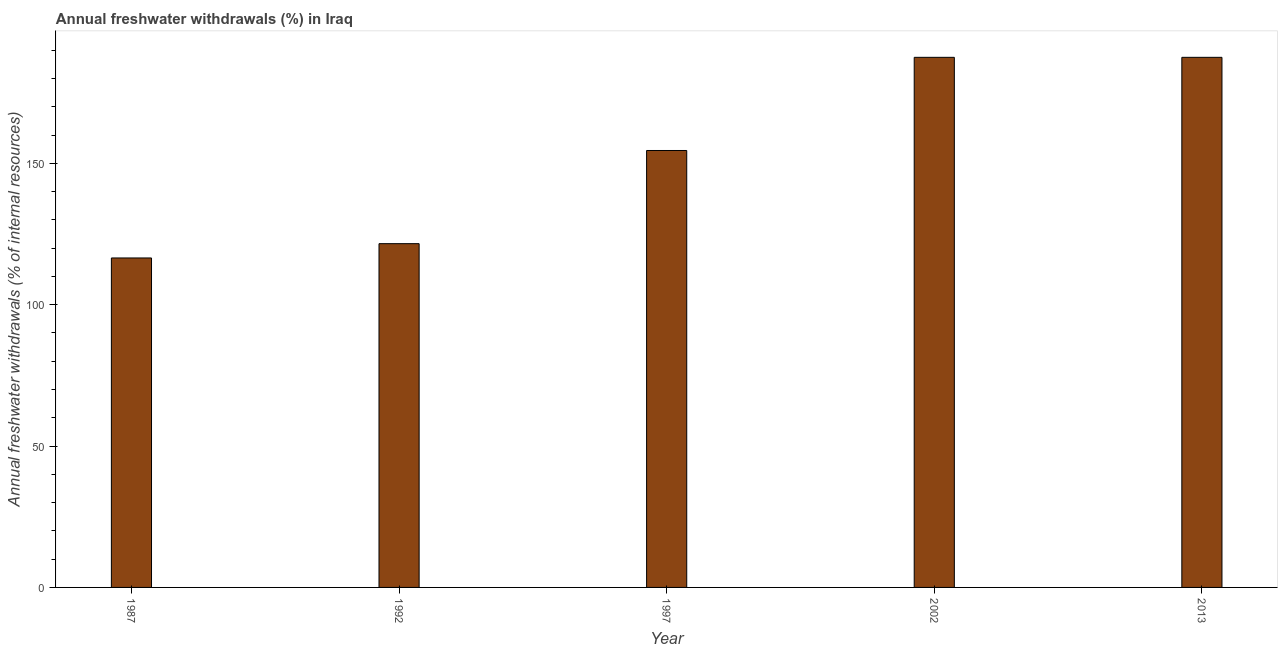Does the graph contain any zero values?
Your response must be concise. No. What is the title of the graph?
Give a very brief answer. Annual freshwater withdrawals (%) in Iraq. What is the label or title of the Y-axis?
Keep it short and to the point. Annual freshwater withdrawals (% of internal resources). What is the annual freshwater withdrawals in 1992?
Keep it short and to the point. 121.59. Across all years, what is the maximum annual freshwater withdrawals?
Offer a very short reply. 187.5. Across all years, what is the minimum annual freshwater withdrawals?
Keep it short and to the point. 116.53. In which year was the annual freshwater withdrawals maximum?
Give a very brief answer. 2002. In which year was the annual freshwater withdrawals minimum?
Ensure brevity in your answer.  1987. What is the sum of the annual freshwater withdrawals?
Ensure brevity in your answer.  767.67. What is the difference between the annual freshwater withdrawals in 1987 and 2002?
Provide a short and direct response. -70.97. What is the average annual freshwater withdrawals per year?
Ensure brevity in your answer.  153.53. What is the median annual freshwater withdrawals?
Make the answer very short. 154.55. In how many years, is the annual freshwater withdrawals greater than 120 %?
Offer a very short reply. 4. Do a majority of the years between 2002 and 1997 (inclusive) have annual freshwater withdrawals greater than 140 %?
Keep it short and to the point. No. What is the ratio of the annual freshwater withdrawals in 1992 to that in 2002?
Offer a very short reply. 0.65. Is the annual freshwater withdrawals in 1987 less than that in 2013?
Your answer should be compact. Yes. Is the difference between the annual freshwater withdrawals in 1987 and 2002 greater than the difference between any two years?
Provide a succinct answer. Yes. What is the difference between the highest and the second highest annual freshwater withdrawals?
Give a very brief answer. 0. What is the difference between the highest and the lowest annual freshwater withdrawals?
Give a very brief answer. 70.97. In how many years, is the annual freshwater withdrawals greater than the average annual freshwater withdrawals taken over all years?
Provide a succinct answer. 3. How many years are there in the graph?
Keep it short and to the point. 5. Are the values on the major ticks of Y-axis written in scientific E-notation?
Provide a short and direct response. No. What is the Annual freshwater withdrawals (% of internal resources) of 1987?
Ensure brevity in your answer.  116.53. What is the Annual freshwater withdrawals (% of internal resources) in 1992?
Make the answer very short. 121.59. What is the Annual freshwater withdrawals (% of internal resources) in 1997?
Ensure brevity in your answer.  154.55. What is the Annual freshwater withdrawals (% of internal resources) of 2002?
Your answer should be compact. 187.5. What is the Annual freshwater withdrawals (% of internal resources) of 2013?
Ensure brevity in your answer.  187.5. What is the difference between the Annual freshwater withdrawals (% of internal resources) in 1987 and 1992?
Provide a short and direct response. -5.06. What is the difference between the Annual freshwater withdrawals (% of internal resources) in 1987 and 1997?
Offer a terse response. -38.01. What is the difference between the Annual freshwater withdrawals (% of internal resources) in 1987 and 2002?
Make the answer very short. -70.97. What is the difference between the Annual freshwater withdrawals (% of internal resources) in 1987 and 2013?
Your answer should be compact. -70.97. What is the difference between the Annual freshwater withdrawals (% of internal resources) in 1992 and 1997?
Your answer should be very brief. -32.95. What is the difference between the Annual freshwater withdrawals (% of internal resources) in 1992 and 2002?
Offer a terse response. -65.91. What is the difference between the Annual freshwater withdrawals (% of internal resources) in 1992 and 2013?
Make the answer very short. -65.91. What is the difference between the Annual freshwater withdrawals (% of internal resources) in 1997 and 2002?
Your response must be concise. -32.95. What is the difference between the Annual freshwater withdrawals (% of internal resources) in 1997 and 2013?
Make the answer very short. -32.95. What is the ratio of the Annual freshwater withdrawals (% of internal resources) in 1987 to that in 1992?
Keep it short and to the point. 0.96. What is the ratio of the Annual freshwater withdrawals (% of internal resources) in 1987 to that in 1997?
Offer a terse response. 0.75. What is the ratio of the Annual freshwater withdrawals (% of internal resources) in 1987 to that in 2002?
Give a very brief answer. 0.62. What is the ratio of the Annual freshwater withdrawals (% of internal resources) in 1987 to that in 2013?
Give a very brief answer. 0.62. What is the ratio of the Annual freshwater withdrawals (% of internal resources) in 1992 to that in 1997?
Make the answer very short. 0.79. What is the ratio of the Annual freshwater withdrawals (% of internal resources) in 1992 to that in 2002?
Offer a terse response. 0.65. What is the ratio of the Annual freshwater withdrawals (% of internal resources) in 1992 to that in 2013?
Your response must be concise. 0.65. What is the ratio of the Annual freshwater withdrawals (% of internal resources) in 1997 to that in 2002?
Offer a very short reply. 0.82. What is the ratio of the Annual freshwater withdrawals (% of internal resources) in 1997 to that in 2013?
Ensure brevity in your answer.  0.82. What is the ratio of the Annual freshwater withdrawals (% of internal resources) in 2002 to that in 2013?
Your answer should be compact. 1. 